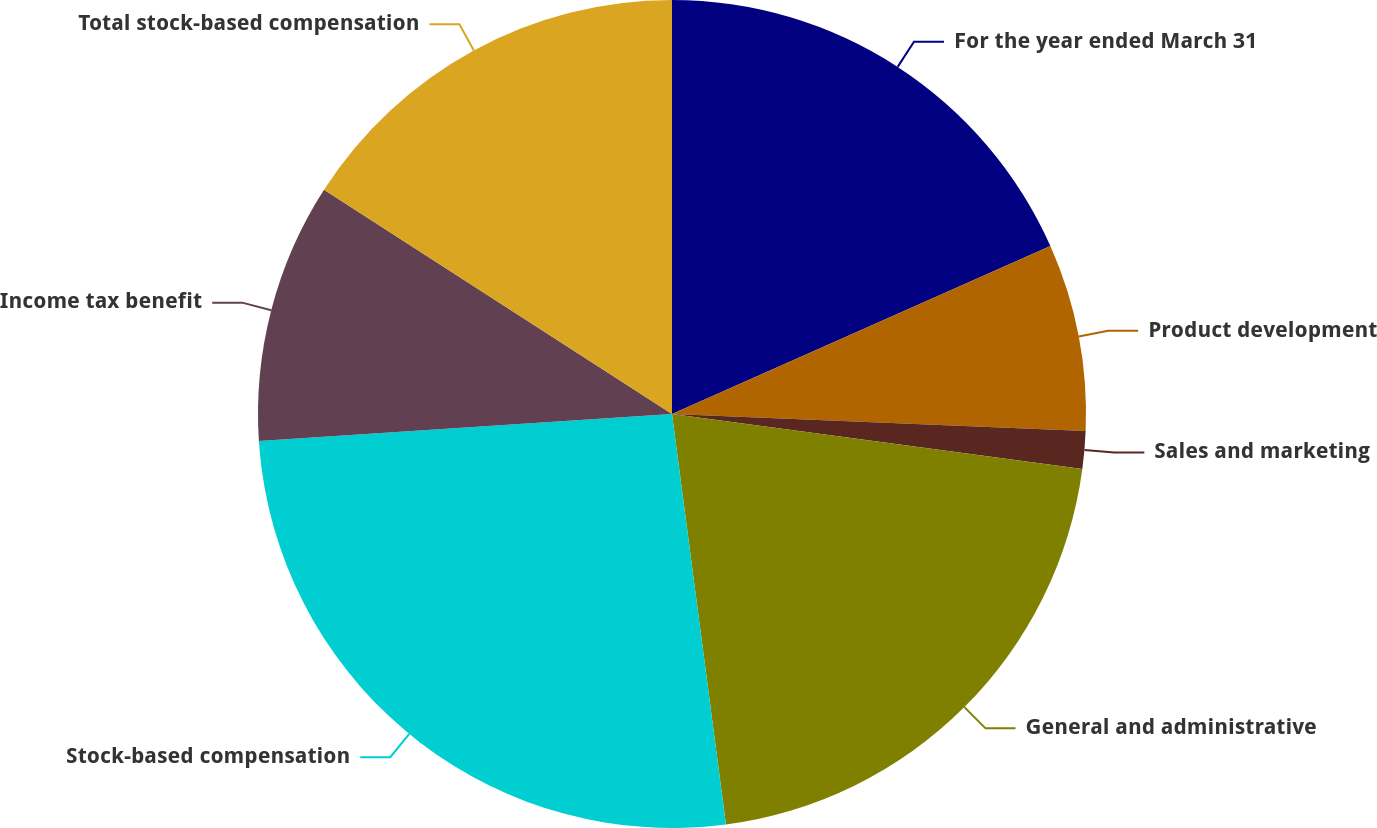Convert chart. <chart><loc_0><loc_0><loc_500><loc_500><pie_chart><fcel>For the year ended March 31<fcel>Product development<fcel>Sales and marketing<fcel>General and administrative<fcel>Stock-based compensation<fcel>Income tax benefit<fcel>Total stock-based compensation<nl><fcel>18.35%<fcel>7.3%<fcel>1.47%<fcel>20.8%<fcel>26.04%<fcel>10.15%<fcel>15.89%<nl></chart> 